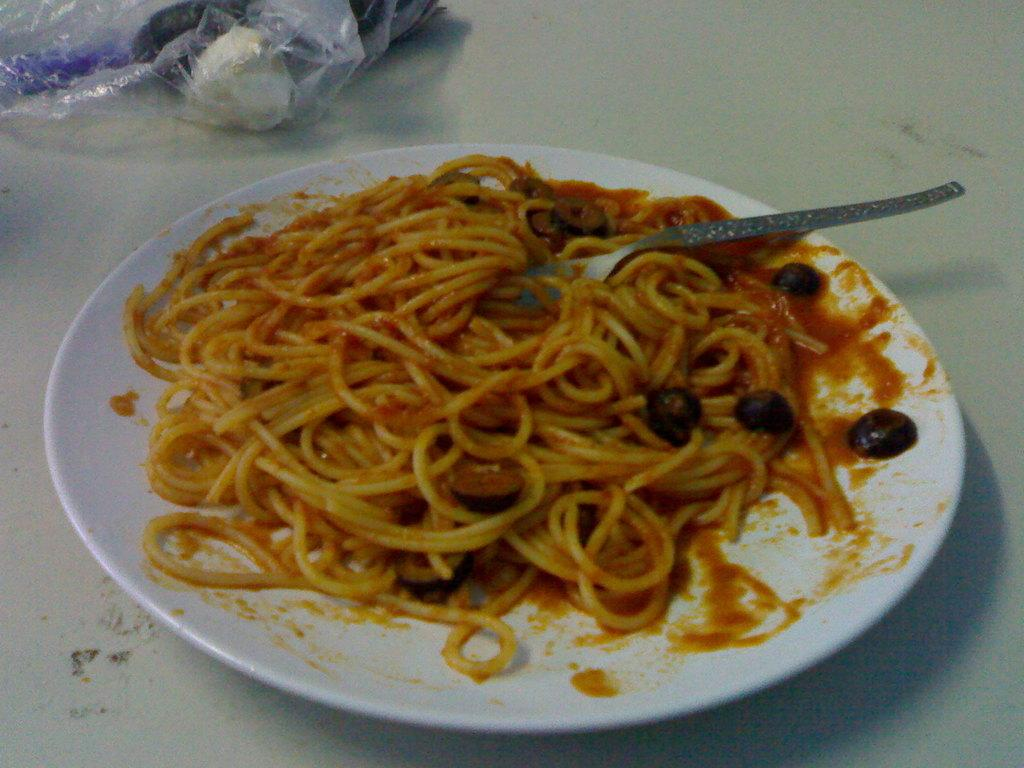What is present on the plate in the image? There is food on the plate in the image. What utensil is visible in the image? There is a spoon in the image. What else is covered in the image? There is a cover with items in the image. Can you describe the desk in the image? There is no desk present in the image. What type of airplane is visible in the image? There is no airplane present in the image. 